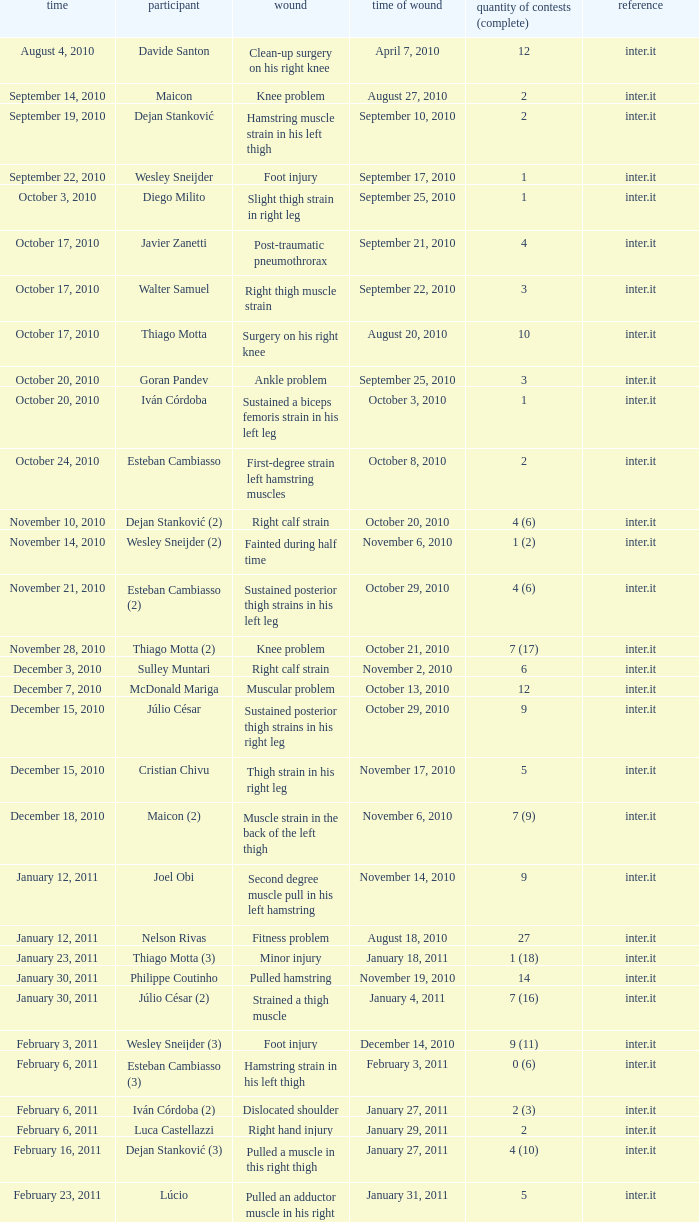What is the date of injury for player Wesley sneijder (2)? November 6, 2010. 